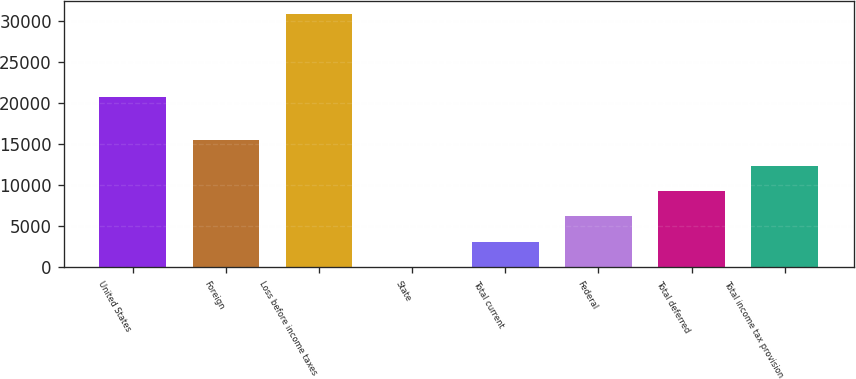<chart> <loc_0><loc_0><loc_500><loc_500><bar_chart><fcel>United States<fcel>Foreign<fcel>Loss before income taxes<fcel>State<fcel>Total current<fcel>Federal<fcel>Total deferred<fcel>Total income tax provision<nl><fcel>20672<fcel>15438.5<fcel>30845<fcel>32<fcel>3113.3<fcel>6194.6<fcel>9275.9<fcel>12357.2<nl></chart> 